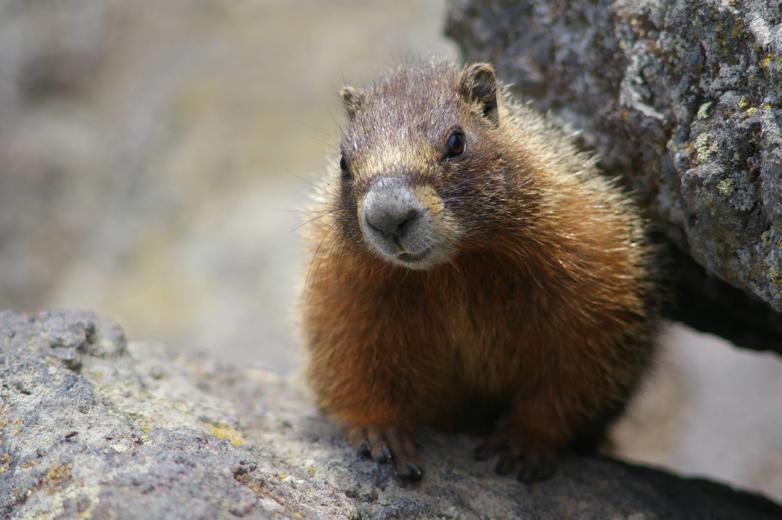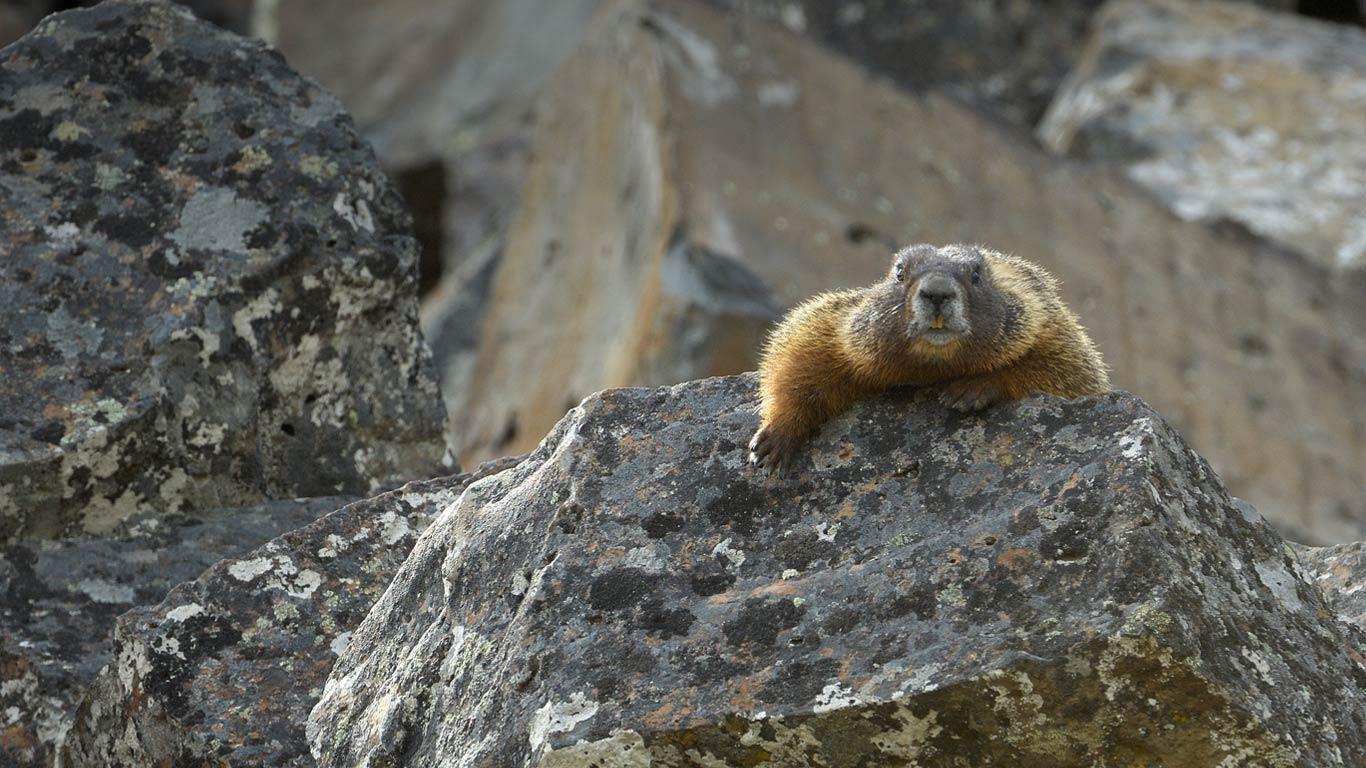The first image is the image on the left, the second image is the image on the right. Examine the images to the left and right. Is the description "The marmots in the two images appear to face each other." accurate? Answer yes or no. No. The first image is the image on the left, the second image is the image on the right. For the images shown, is this caption "The animal in the image to the left is clearly much more red than it's paired image." true? Answer yes or no. No. 